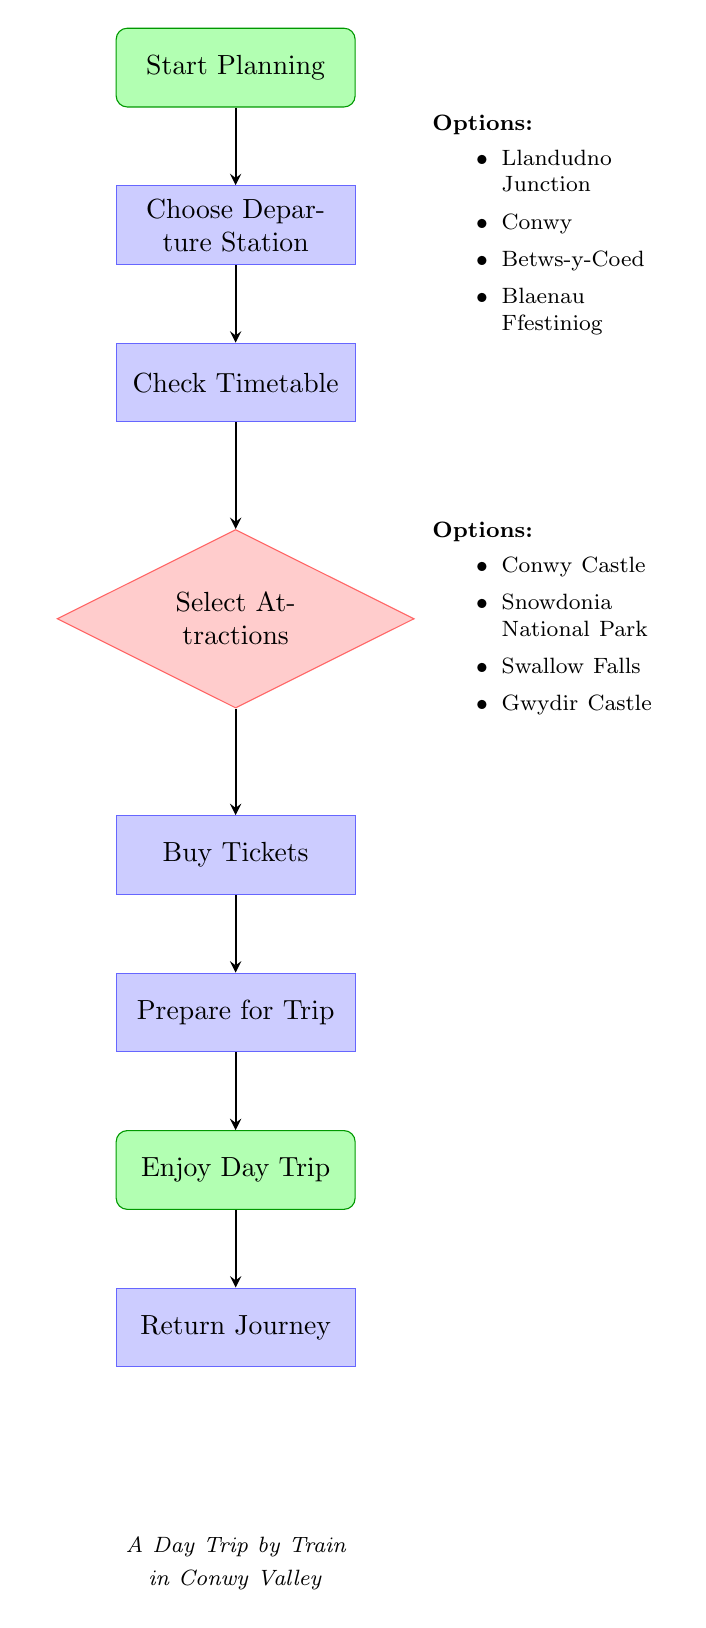What is the first step in the flow chart? The first step in the flow chart is "Start Planning." It is the initial node from which all other steps follow, indicating the beginning of the planning process for a day trip by train in Conwy Valley.
Answer: Start Planning How many nodes are in the diagram? The diagram contains a total of 8 nodes, which represent various steps and decisions in planning the day trip.
Answer: 8 What comes after checking the timetable? After checking the timetable, the next step is "Select Attractions." This is the node that follows in the sequence of steps outlined in the flow chart.
Answer: Select Attractions What are the options for the departure station? The options for the departure station include Llandudno Junction, Conwy, Betws-y-Coed, and Blaenau Ffestiniog. These stations are listed beside the "Choose Departure Station" node.
Answer: Llandudno Junction, Conwy, Betws-y-Coed, Blaenau Ffestiniog What is the final activity in the diagram? The final activity in the diagram is "Return Journey," which indicates the end of the trip where one catches the train back after enjoying the day.
Answer: Return Journey After preparing for the trip, what is the next step? After preparing for the trip, the next step is "Enjoy Day Trip." This indicates that once preparations are made, the traveler can then set off to enjoy the attractions planned.
Answer: Enjoy Day Trip Which step involves purchasing tickets? The step that involves purchasing tickets is "Buy Tickets." This follows the selection of attractions and is essential for proceeding with the trip.
Answer: Buy Tickets What nodes are involved in the process before selecting attractions? The nodes involved before selecting attractions are "Start Planning," "Choose Departure Station," and "Check Timetable." Each of these steps must be completed prior to making selections about attractions.
Answer: Start Planning, Choose Departure Station, Check Timetable 